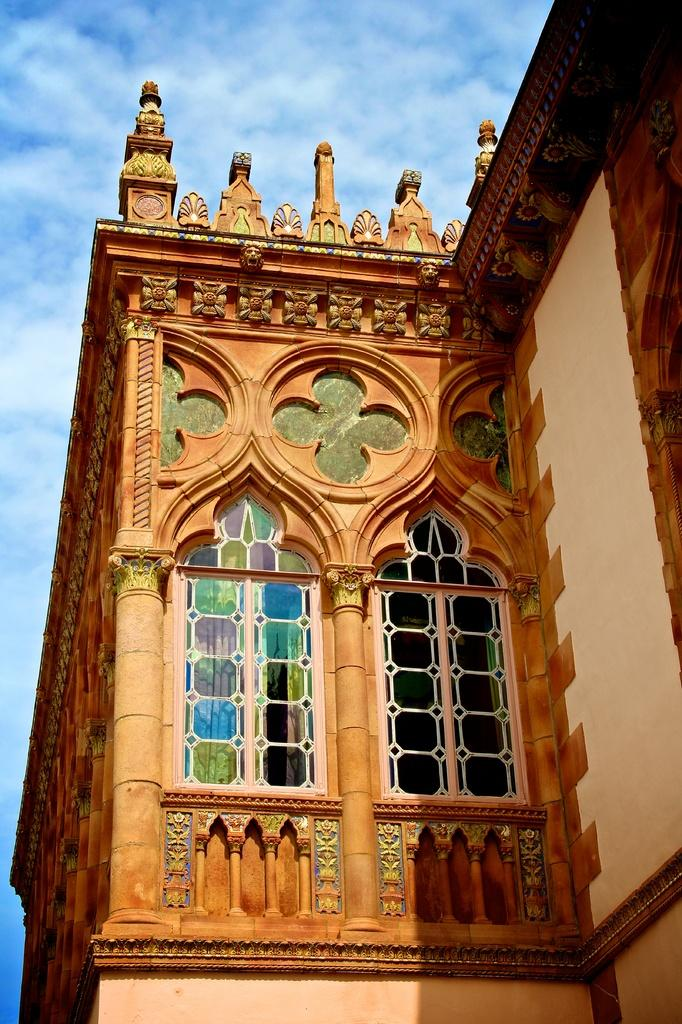What type of structure is present in the image? There is a building in the image. What can be seen in the background of the image? The sky is visible in the background of the image. How many pigs are standing on the sidewalk in the image? There are no pigs or sidewalks present in the image. 